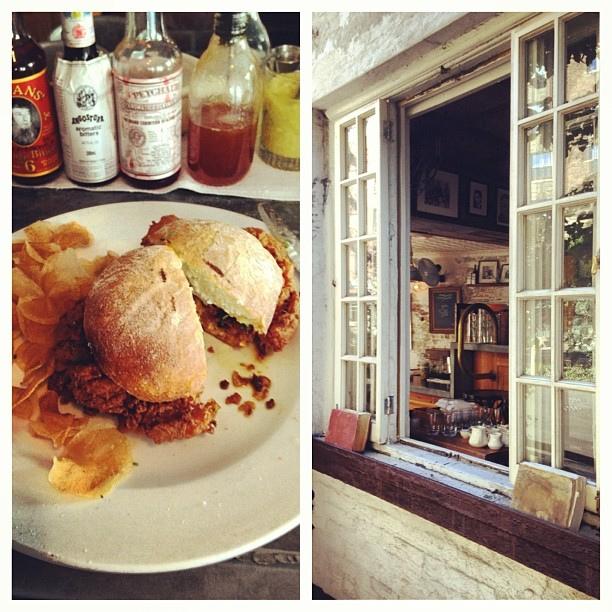What in on the windowsill?
Short answer required. Books. How many bottles are visible in the left picture?
Concise answer only. 4. What sandwich is this?
Concise answer only. Sloppy joe. 